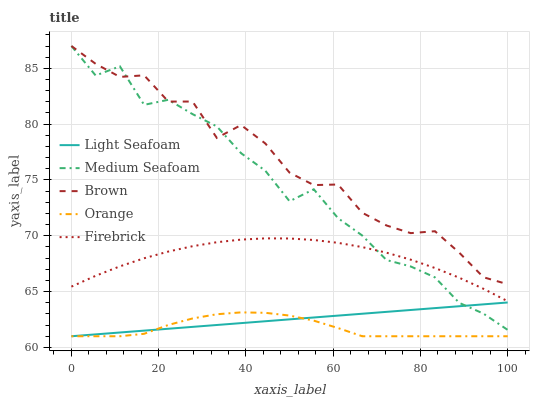Does Orange have the minimum area under the curve?
Answer yes or no. Yes. Does Brown have the maximum area under the curve?
Answer yes or no. Yes. Does Firebrick have the minimum area under the curve?
Answer yes or no. No. Does Firebrick have the maximum area under the curve?
Answer yes or no. No. Is Light Seafoam the smoothest?
Answer yes or no. Yes. Is Medium Seafoam the roughest?
Answer yes or no. Yes. Is Brown the smoothest?
Answer yes or no. No. Is Brown the roughest?
Answer yes or no. No. Does Firebrick have the lowest value?
Answer yes or no. No. Does Firebrick have the highest value?
Answer yes or no. No. Is Light Seafoam less than Firebrick?
Answer yes or no. Yes. Is Brown greater than Orange?
Answer yes or no. Yes. Does Light Seafoam intersect Firebrick?
Answer yes or no. No. 